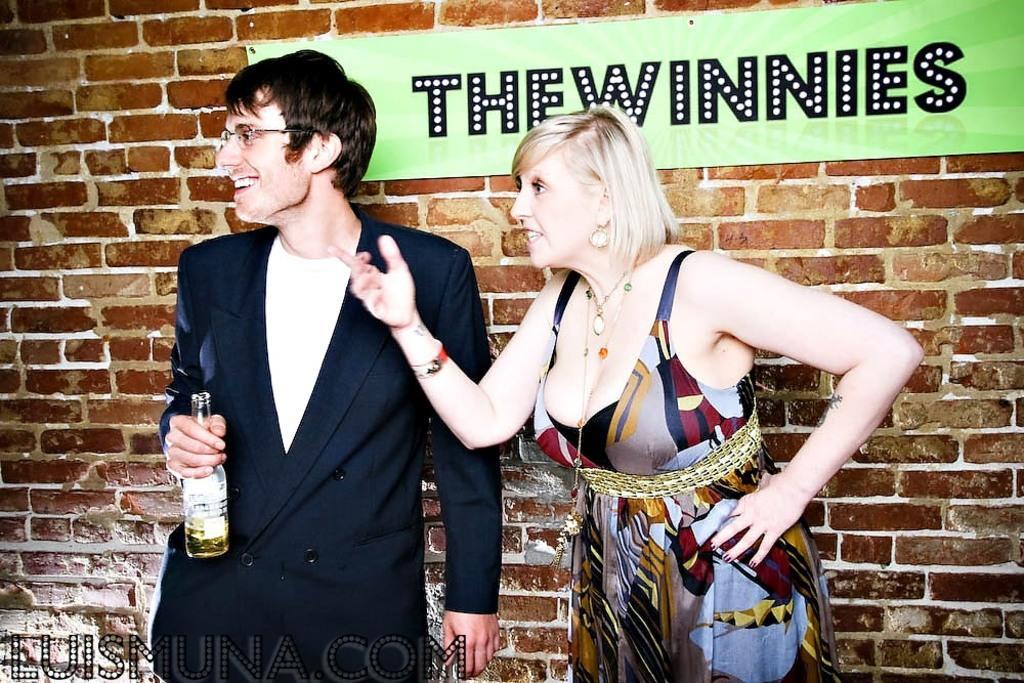How would you summarize this image in a sentence or two? In the picture we can see a man and a woman are standing, man is in a blazer, white T-shirt and he is holding a wine bottle and behind them we can see a wall with a name on it as the whinnies. 